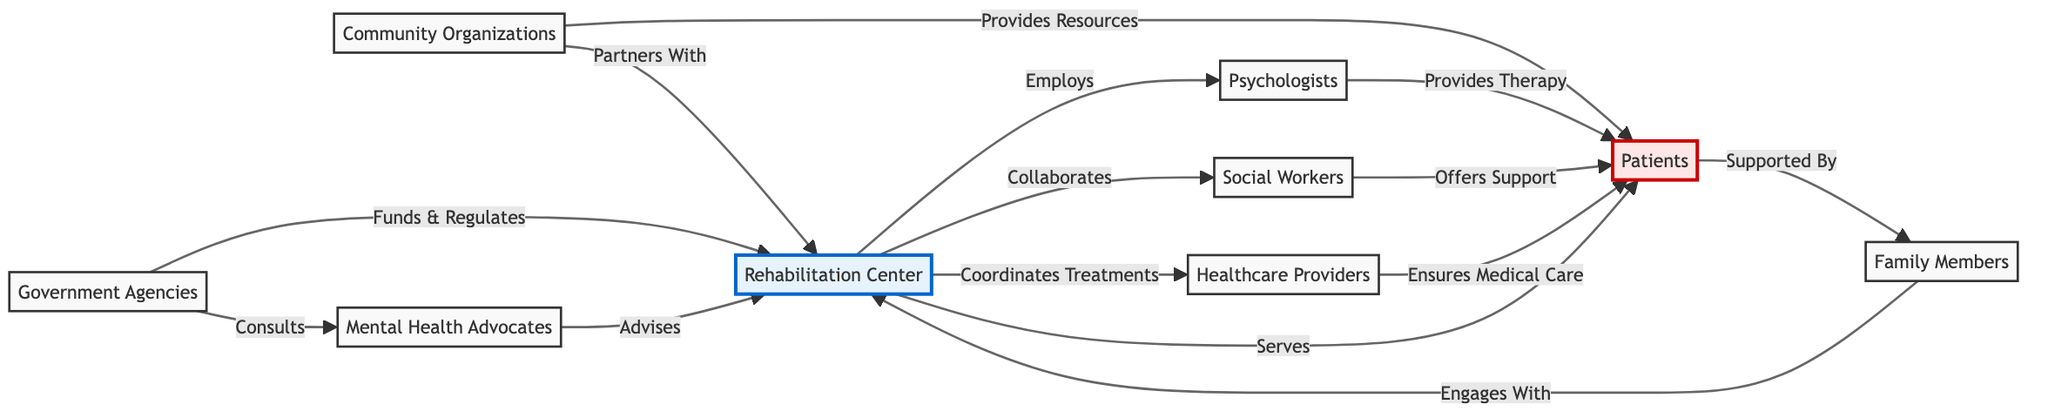What is the role of psychologists in the network? Psychologists are connected to patients through the "Provides Therapy" relationship, indicating that their primary role is to provide therapy to assist patients in their rehabilitation journeys.
Answer: Provides Therapy How many main stakeholders are represented in the diagram? The diagram depicts a total of eight main stakeholders: Rehabilitation Center, Psychologists, Social Workers, Healthcare Providers, Patients, Family Members, Community Organizations, Government Agencies, and Mental Health Advocates, summing up to eight distinct nodes.
Answer: Eight Which stakeholders provide support directly to patients? Three stakeholders (Psychologists, Social Workers, and Healthcare Providers) provide direct support or services to patients as seen in their respective relationships originating from their nodes.
Answer: Three What is the relationship between community organizations and the rehabilitation center? The relationship between community organizations and the rehabilitation center is twofold: community organizations "Provides Resources" to patients and "Partners With" the rehabilitation center, indicating a collaborative role.
Answer: Provides Resources & Partners With What role do government agencies play in relation to the rehabilitation center? Government agencies have a dual role affecting the rehabilitation center: they "Funds & Regulates" its operations and "Consults" with mental health advocates, indicating both financial oversight and advisory engagement.
Answer: Funds & Regulates & Consults Which entity directly engages with family members in the ecosystem? Family members engage directly with the rehabilitation center, as signified in the node relationship "Engages With," demonstrating their interaction and communication channels with the center for emotional support.
Answer: Engages With How do mental health advocates influence the rehabilitation center? Mental health advocates influence the rehabilitation center by "Advises," which suggests they offer guidance or recommendations, contributing to the development and improvement of rehabilitation methods.
Answer: Advises What type of support does the social workers provide to the patients? Social workers provide support to patients by "Offers Support," which indicates their role in assisting patients through emotional, social, or practical means during the rehabilitation process.
Answer: Offers Support How do family members interact with the rehabilitation center? Family members interact with the rehabilitation center through the relationship defined as "Engages With," reflecting their involvement in the rehabilitation process and support for the patient.
Answer: Engages With 